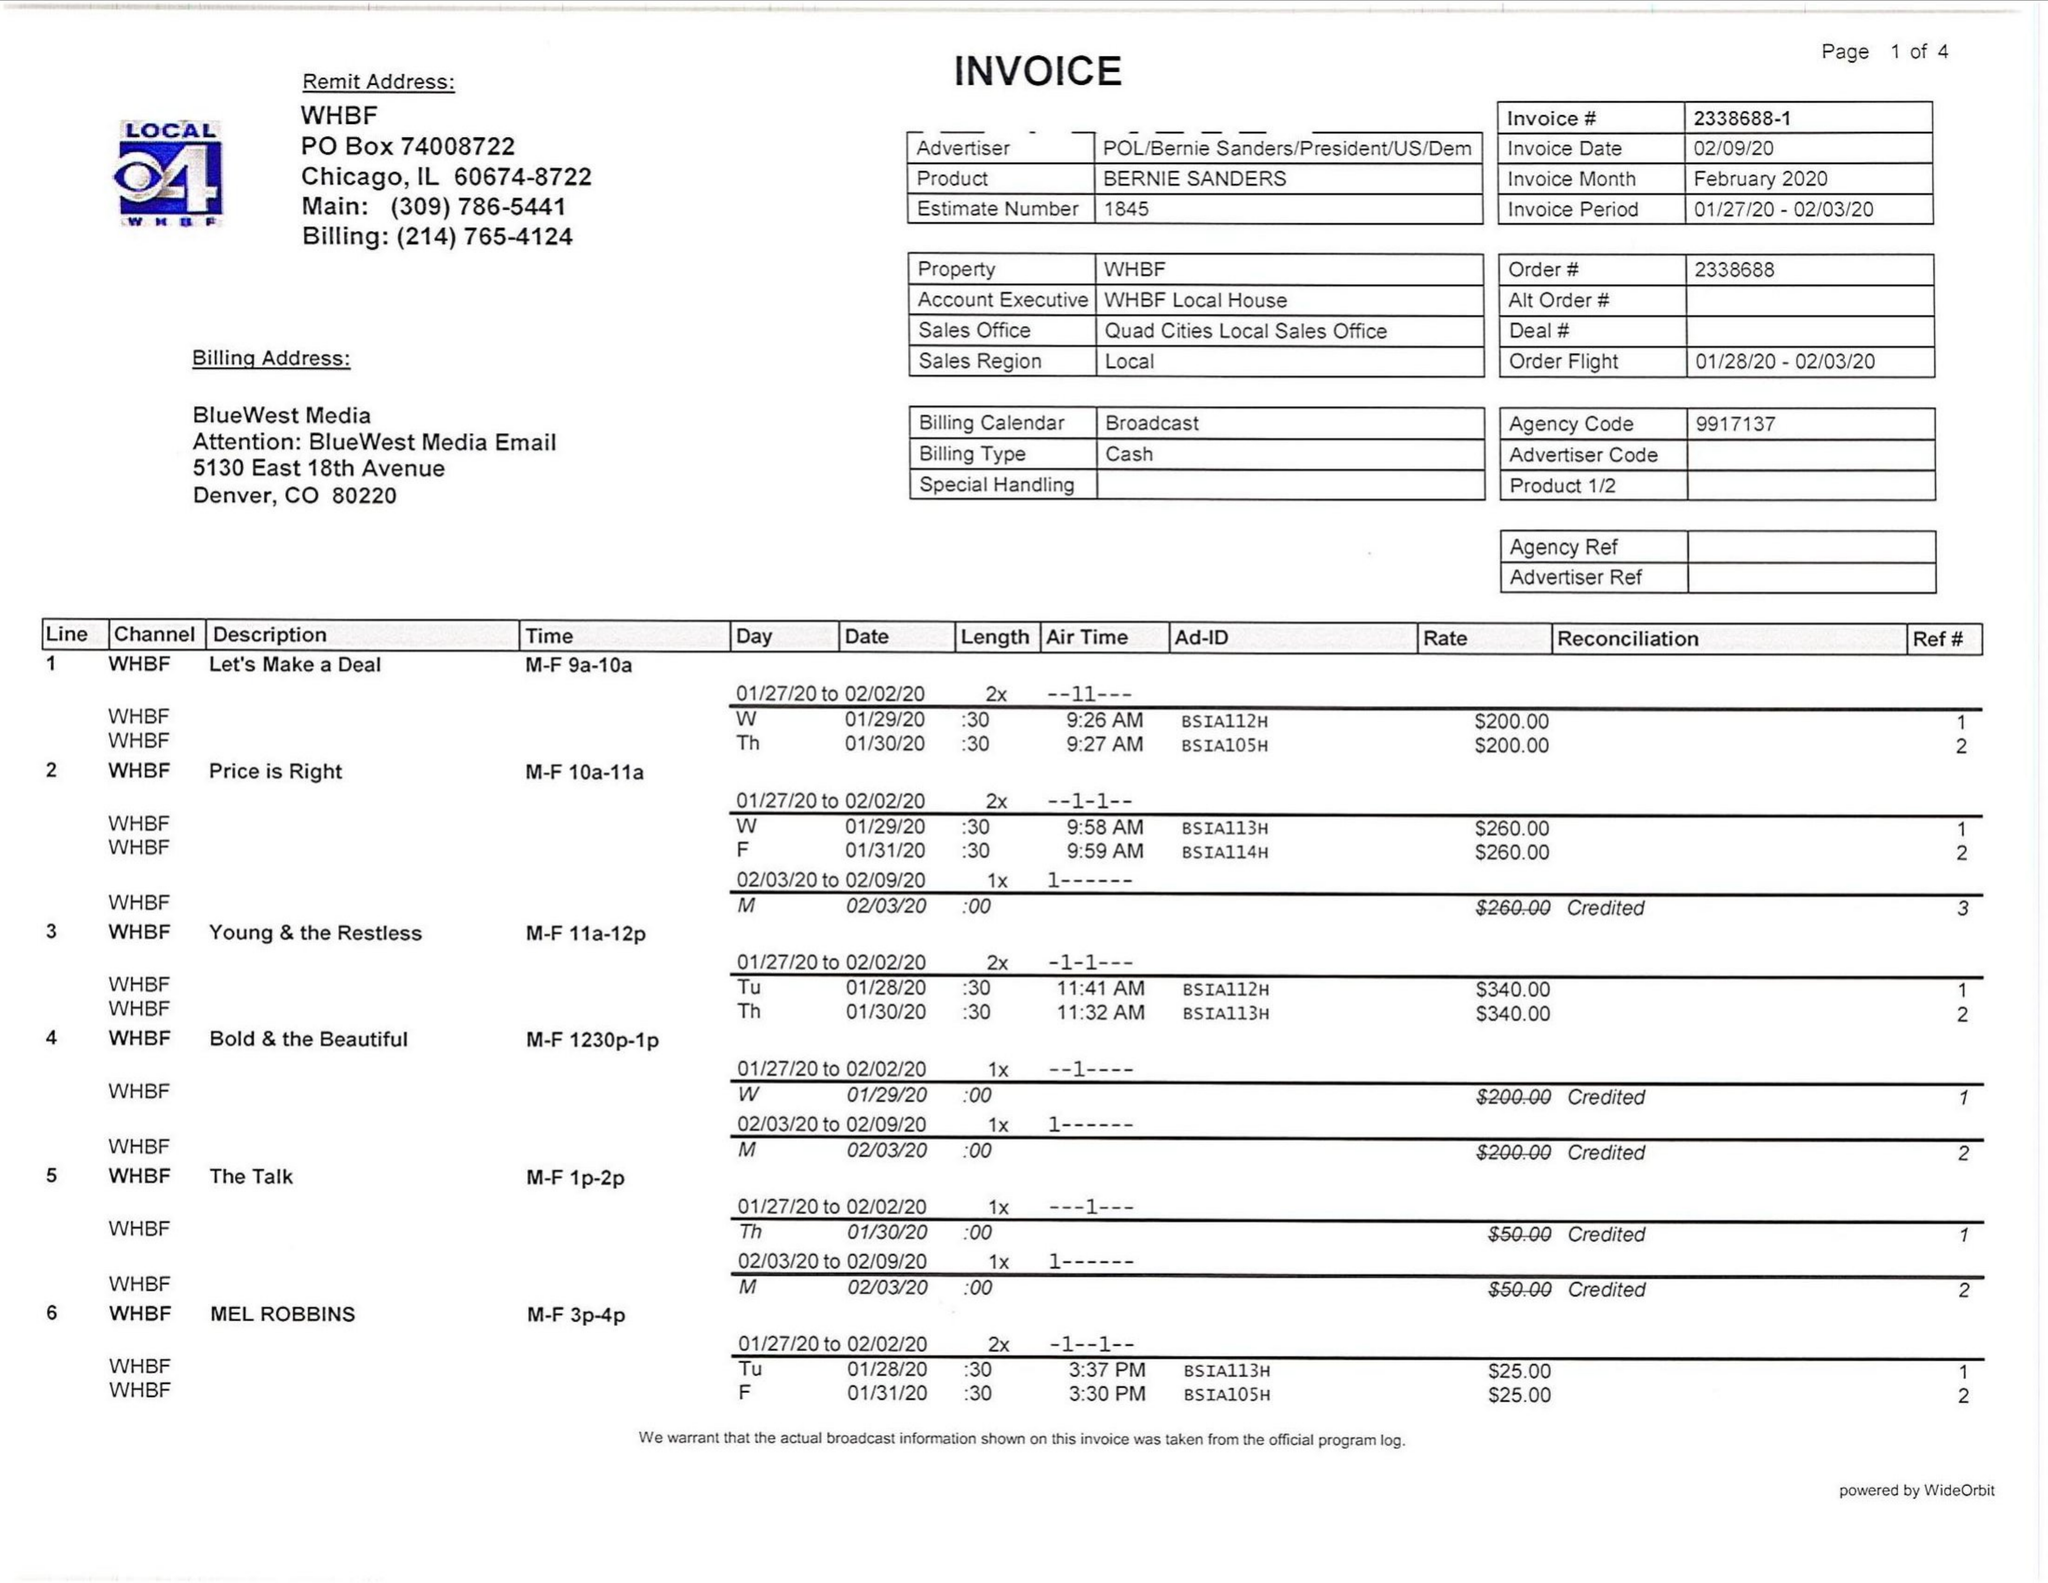What is the value for the advertiser?
Answer the question using a single word or phrase. POL/BERNIESANDERS/PRESIDENT/US/DEM 